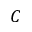<formula> <loc_0><loc_0><loc_500><loc_500>C</formula> 